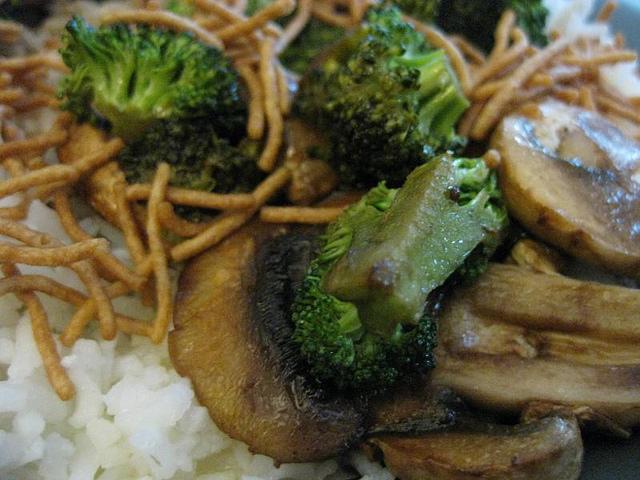What is the vegetable in this dish other than the broccoli?
Answer the question by selecting the correct answer among the 4 following choices.
Options: Potatoes, carrots, onions, mushrooms. Mushrooms. 